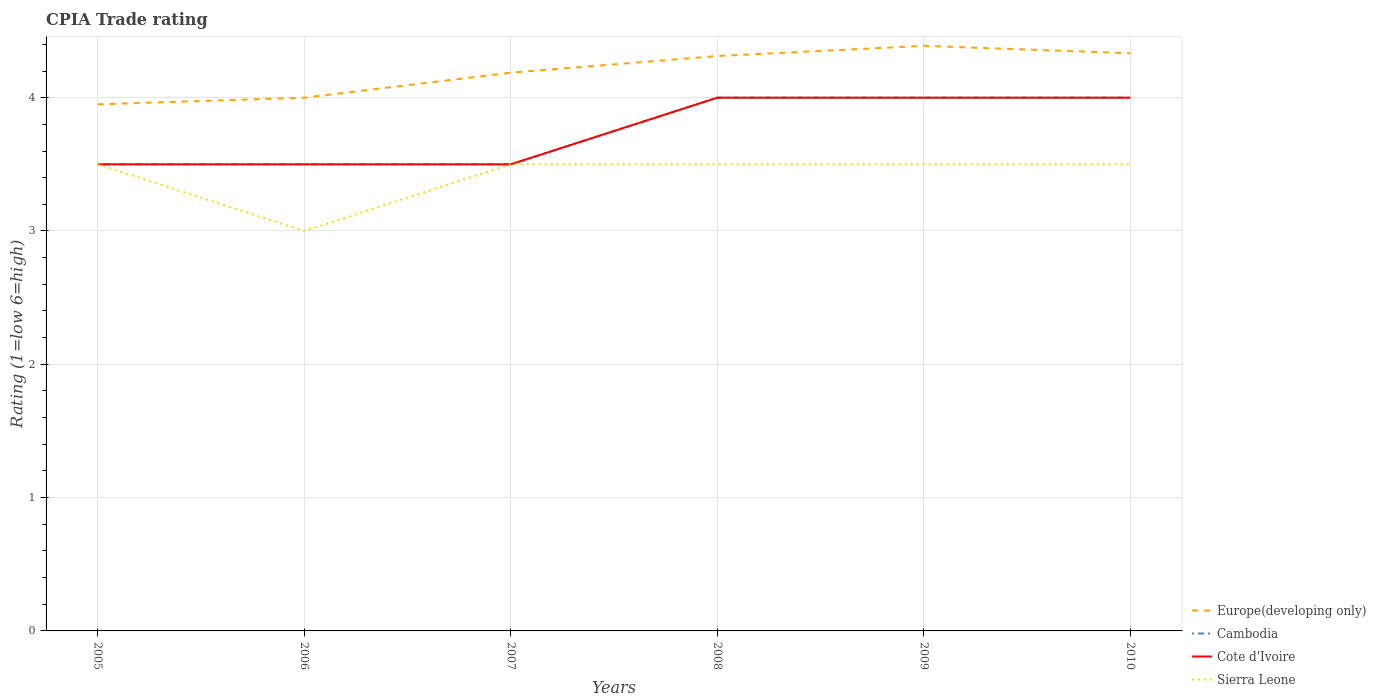How many different coloured lines are there?
Make the answer very short. 4. Does the line corresponding to Sierra Leone intersect with the line corresponding to Cote d'Ivoire?
Your answer should be compact. Yes. Is the number of lines equal to the number of legend labels?
Your answer should be compact. Yes. Across all years, what is the maximum CPIA rating in Sierra Leone?
Provide a short and direct response. 3. In which year was the CPIA rating in Sierra Leone maximum?
Offer a terse response. 2006. What is the total CPIA rating in Europe(developing only) in the graph?
Your answer should be very brief. -0.38. What is the difference between the highest and the lowest CPIA rating in Europe(developing only)?
Give a very brief answer. 3. Where does the legend appear in the graph?
Make the answer very short. Bottom right. How many legend labels are there?
Your answer should be compact. 4. How are the legend labels stacked?
Ensure brevity in your answer.  Vertical. What is the title of the graph?
Your response must be concise. CPIA Trade rating. Does "Macao" appear as one of the legend labels in the graph?
Your response must be concise. No. What is the label or title of the X-axis?
Make the answer very short. Years. What is the label or title of the Y-axis?
Your answer should be compact. Rating (1=low 6=high). What is the Rating (1=low 6=high) of Europe(developing only) in 2005?
Offer a terse response. 3.95. What is the Rating (1=low 6=high) of Sierra Leone in 2005?
Your response must be concise. 3.5. What is the Rating (1=low 6=high) in Europe(developing only) in 2006?
Ensure brevity in your answer.  4. What is the Rating (1=low 6=high) of Cambodia in 2006?
Your answer should be very brief. 3.5. What is the Rating (1=low 6=high) of Cote d'Ivoire in 2006?
Provide a short and direct response. 3.5. What is the Rating (1=low 6=high) in Sierra Leone in 2006?
Give a very brief answer. 3. What is the Rating (1=low 6=high) in Europe(developing only) in 2007?
Keep it short and to the point. 4.19. What is the Rating (1=low 6=high) in Cambodia in 2007?
Your answer should be very brief. 3.5. What is the Rating (1=low 6=high) of Cote d'Ivoire in 2007?
Offer a terse response. 3.5. What is the Rating (1=low 6=high) in Sierra Leone in 2007?
Ensure brevity in your answer.  3.5. What is the Rating (1=low 6=high) of Europe(developing only) in 2008?
Keep it short and to the point. 4.31. What is the Rating (1=low 6=high) of Cote d'Ivoire in 2008?
Your answer should be very brief. 4. What is the Rating (1=low 6=high) in Europe(developing only) in 2009?
Your answer should be very brief. 4.39. What is the Rating (1=low 6=high) in Cote d'Ivoire in 2009?
Offer a very short reply. 4. What is the Rating (1=low 6=high) in Europe(developing only) in 2010?
Give a very brief answer. 4.33. Across all years, what is the maximum Rating (1=low 6=high) of Europe(developing only)?
Provide a short and direct response. 4.39. Across all years, what is the maximum Rating (1=low 6=high) in Sierra Leone?
Provide a short and direct response. 3.5. Across all years, what is the minimum Rating (1=low 6=high) in Europe(developing only)?
Ensure brevity in your answer.  3.95. Across all years, what is the minimum Rating (1=low 6=high) in Cote d'Ivoire?
Offer a terse response. 3.5. What is the total Rating (1=low 6=high) of Europe(developing only) in the graph?
Offer a terse response. 25.17. What is the total Rating (1=low 6=high) in Cote d'Ivoire in the graph?
Give a very brief answer. 22.5. What is the difference between the Rating (1=low 6=high) in Europe(developing only) in 2005 and that in 2006?
Make the answer very short. -0.05. What is the difference between the Rating (1=low 6=high) of Cambodia in 2005 and that in 2006?
Make the answer very short. 0. What is the difference between the Rating (1=low 6=high) of Europe(developing only) in 2005 and that in 2007?
Make the answer very short. -0.24. What is the difference between the Rating (1=low 6=high) of Sierra Leone in 2005 and that in 2007?
Make the answer very short. 0. What is the difference between the Rating (1=low 6=high) in Europe(developing only) in 2005 and that in 2008?
Your response must be concise. -0.36. What is the difference between the Rating (1=low 6=high) in Cambodia in 2005 and that in 2008?
Offer a very short reply. -0.5. What is the difference between the Rating (1=low 6=high) of Europe(developing only) in 2005 and that in 2009?
Your response must be concise. -0.44. What is the difference between the Rating (1=low 6=high) of Cambodia in 2005 and that in 2009?
Keep it short and to the point. -0.5. What is the difference between the Rating (1=low 6=high) in Cote d'Ivoire in 2005 and that in 2009?
Offer a very short reply. -0.5. What is the difference between the Rating (1=low 6=high) of Sierra Leone in 2005 and that in 2009?
Offer a very short reply. 0. What is the difference between the Rating (1=low 6=high) of Europe(developing only) in 2005 and that in 2010?
Ensure brevity in your answer.  -0.38. What is the difference between the Rating (1=low 6=high) in Europe(developing only) in 2006 and that in 2007?
Ensure brevity in your answer.  -0.19. What is the difference between the Rating (1=low 6=high) in Cambodia in 2006 and that in 2007?
Your answer should be very brief. 0. What is the difference between the Rating (1=low 6=high) of Sierra Leone in 2006 and that in 2007?
Provide a succinct answer. -0.5. What is the difference between the Rating (1=low 6=high) of Europe(developing only) in 2006 and that in 2008?
Make the answer very short. -0.31. What is the difference between the Rating (1=low 6=high) of Cambodia in 2006 and that in 2008?
Give a very brief answer. -0.5. What is the difference between the Rating (1=low 6=high) in Sierra Leone in 2006 and that in 2008?
Keep it short and to the point. -0.5. What is the difference between the Rating (1=low 6=high) in Europe(developing only) in 2006 and that in 2009?
Your answer should be very brief. -0.39. What is the difference between the Rating (1=low 6=high) of Cote d'Ivoire in 2006 and that in 2009?
Your response must be concise. -0.5. What is the difference between the Rating (1=low 6=high) of Sierra Leone in 2006 and that in 2009?
Your response must be concise. -0.5. What is the difference between the Rating (1=low 6=high) of Cambodia in 2006 and that in 2010?
Provide a succinct answer. -0.5. What is the difference between the Rating (1=low 6=high) of Cote d'Ivoire in 2006 and that in 2010?
Provide a succinct answer. -0.5. What is the difference between the Rating (1=low 6=high) in Sierra Leone in 2006 and that in 2010?
Offer a very short reply. -0.5. What is the difference between the Rating (1=low 6=high) in Europe(developing only) in 2007 and that in 2008?
Your answer should be very brief. -0.12. What is the difference between the Rating (1=low 6=high) of Cambodia in 2007 and that in 2008?
Give a very brief answer. -0.5. What is the difference between the Rating (1=low 6=high) of Cote d'Ivoire in 2007 and that in 2008?
Offer a terse response. -0.5. What is the difference between the Rating (1=low 6=high) of Sierra Leone in 2007 and that in 2008?
Keep it short and to the point. 0. What is the difference between the Rating (1=low 6=high) of Europe(developing only) in 2007 and that in 2009?
Offer a terse response. -0.2. What is the difference between the Rating (1=low 6=high) in Cambodia in 2007 and that in 2009?
Ensure brevity in your answer.  -0.5. What is the difference between the Rating (1=low 6=high) of Cote d'Ivoire in 2007 and that in 2009?
Make the answer very short. -0.5. What is the difference between the Rating (1=low 6=high) in Sierra Leone in 2007 and that in 2009?
Provide a succinct answer. 0. What is the difference between the Rating (1=low 6=high) of Europe(developing only) in 2007 and that in 2010?
Give a very brief answer. -0.15. What is the difference between the Rating (1=low 6=high) in Cambodia in 2007 and that in 2010?
Offer a terse response. -0.5. What is the difference between the Rating (1=low 6=high) in Sierra Leone in 2007 and that in 2010?
Your response must be concise. 0. What is the difference between the Rating (1=low 6=high) of Europe(developing only) in 2008 and that in 2009?
Ensure brevity in your answer.  -0.08. What is the difference between the Rating (1=low 6=high) of Cambodia in 2008 and that in 2009?
Your answer should be compact. 0. What is the difference between the Rating (1=low 6=high) of Sierra Leone in 2008 and that in 2009?
Provide a succinct answer. 0. What is the difference between the Rating (1=low 6=high) of Europe(developing only) in 2008 and that in 2010?
Your answer should be compact. -0.02. What is the difference between the Rating (1=low 6=high) in Sierra Leone in 2008 and that in 2010?
Make the answer very short. 0. What is the difference between the Rating (1=low 6=high) in Europe(developing only) in 2009 and that in 2010?
Your answer should be compact. 0.06. What is the difference between the Rating (1=low 6=high) in Cote d'Ivoire in 2009 and that in 2010?
Give a very brief answer. 0. What is the difference between the Rating (1=low 6=high) in Sierra Leone in 2009 and that in 2010?
Offer a terse response. 0. What is the difference between the Rating (1=low 6=high) of Europe(developing only) in 2005 and the Rating (1=low 6=high) of Cambodia in 2006?
Make the answer very short. 0.45. What is the difference between the Rating (1=low 6=high) of Europe(developing only) in 2005 and the Rating (1=low 6=high) of Cote d'Ivoire in 2006?
Your response must be concise. 0.45. What is the difference between the Rating (1=low 6=high) of Europe(developing only) in 2005 and the Rating (1=low 6=high) of Sierra Leone in 2006?
Your response must be concise. 0.95. What is the difference between the Rating (1=low 6=high) in Europe(developing only) in 2005 and the Rating (1=low 6=high) in Cambodia in 2007?
Make the answer very short. 0.45. What is the difference between the Rating (1=low 6=high) in Europe(developing only) in 2005 and the Rating (1=low 6=high) in Cote d'Ivoire in 2007?
Offer a terse response. 0.45. What is the difference between the Rating (1=low 6=high) in Europe(developing only) in 2005 and the Rating (1=low 6=high) in Sierra Leone in 2007?
Keep it short and to the point. 0.45. What is the difference between the Rating (1=low 6=high) in Cambodia in 2005 and the Rating (1=low 6=high) in Cote d'Ivoire in 2007?
Make the answer very short. 0. What is the difference between the Rating (1=low 6=high) in Cote d'Ivoire in 2005 and the Rating (1=low 6=high) in Sierra Leone in 2007?
Provide a succinct answer. 0. What is the difference between the Rating (1=low 6=high) of Europe(developing only) in 2005 and the Rating (1=low 6=high) of Cote d'Ivoire in 2008?
Offer a terse response. -0.05. What is the difference between the Rating (1=low 6=high) of Europe(developing only) in 2005 and the Rating (1=low 6=high) of Sierra Leone in 2008?
Ensure brevity in your answer.  0.45. What is the difference between the Rating (1=low 6=high) of Cambodia in 2005 and the Rating (1=low 6=high) of Sierra Leone in 2008?
Give a very brief answer. 0. What is the difference between the Rating (1=low 6=high) in Europe(developing only) in 2005 and the Rating (1=low 6=high) in Cambodia in 2009?
Give a very brief answer. -0.05. What is the difference between the Rating (1=low 6=high) of Europe(developing only) in 2005 and the Rating (1=low 6=high) of Cote d'Ivoire in 2009?
Provide a short and direct response. -0.05. What is the difference between the Rating (1=low 6=high) in Europe(developing only) in 2005 and the Rating (1=low 6=high) in Sierra Leone in 2009?
Your answer should be compact. 0.45. What is the difference between the Rating (1=low 6=high) in Cambodia in 2005 and the Rating (1=low 6=high) in Cote d'Ivoire in 2009?
Offer a very short reply. -0.5. What is the difference between the Rating (1=low 6=high) in Europe(developing only) in 2005 and the Rating (1=low 6=high) in Cambodia in 2010?
Give a very brief answer. -0.05. What is the difference between the Rating (1=low 6=high) in Europe(developing only) in 2005 and the Rating (1=low 6=high) in Cote d'Ivoire in 2010?
Your answer should be very brief. -0.05. What is the difference between the Rating (1=low 6=high) of Europe(developing only) in 2005 and the Rating (1=low 6=high) of Sierra Leone in 2010?
Ensure brevity in your answer.  0.45. What is the difference between the Rating (1=low 6=high) in Cambodia in 2005 and the Rating (1=low 6=high) in Cote d'Ivoire in 2010?
Give a very brief answer. -0.5. What is the difference between the Rating (1=low 6=high) of Cambodia in 2005 and the Rating (1=low 6=high) of Sierra Leone in 2010?
Make the answer very short. 0. What is the difference between the Rating (1=low 6=high) of Cote d'Ivoire in 2005 and the Rating (1=low 6=high) of Sierra Leone in 2010?
Give a very brief answer. 0. What is the difference between the Rating (1=low 6=high) of Europe(developing only) in 2006 and the Rating (1=low 6=high) of Sierra Leone in 2007?
Provide a succinct answer. 0.5. What is the difference between the Rating (1=low 6=high) of Cote d'Ivoire in 2006 and the Rating (1=low 6=high) of Sierra Leone in 2007?
Give a very brief answer. 0. What is the difference between the Rating (1=low 6=high) in Europe(developing only) in 2006 and the Rating (1=low 6=high) in Cambodia in 2008?
Your answer should be compact. 0. What is the difference between the Rating (1=low 6=high) of Europe(developing only) in 2006 and the Rating (1=low 6=high) of Sierra Leone in 2008?
Offer a very short reply. 0.5. What is the difference between the Rating (1=low 6=high) in Cambodia in 2006 and the Rating (1=low 6=high) in Cote d'Ivoire in 2008?
Offer a terse response. -0.5. What is the difference between the Rating (1=low 6=high) in Cambodia in 2006 and the Rating (1=low 6=high) in Sierra Leone in 2008?
Ensure brevity in your answer.  0. What is the difference between the Rating (1=low 6=high) in Cote d'Ivoire in 2006 and the Rating (1=low 6=high) in Sierra Leone in 2008?
Provide a succinct answer. 0. What is the difference between the Rating (1=low 6=high) in Europe(developing only) in 2006 and the Rating (1=low 6=high) in Cambodia in 2009?
Make the answer very short. 0. What is the difference between the Rating (1=low 6=high) in Europe(developing only) in 2006 and the Rating (1=low 6=high) in Cote d'Ivoire in 2009?
Provide a short and direct response. 0. What is the difference between the Rating (1=low 6=high) in Europe(developing only) in 2006 and the Rating (1=low 6=high) in Sierra Leone in 2009?
Keep it short and to the point. 0.5. What is the difference between the Rating (1=low 6=high) of Cambodia in 2006 and the Rating (1=low 6=high) of Cote d'Ivoire in 2009?
Make the answer very short. -0.5. What is the difference between the Rating (1=low 6=high) in Cote d'Ivoire in 2006 and the Rating (1=low 6=high) in Sierra Leone in 2009?
Ensure brevity in your answer.  0. What is the difference between the Rating (1=low 6=high) of Europe(developing only) in 2006 and the Rating (1=low 6=high) of Cambodia in 2010?
Your answer should be compact. 0. What is the difference between the Rating (1=low 6=high) in Europe(developing only) in 2006 and the Rating (1=low 6=high) in Cote d'Ivoire in 2010?
Offer a terse response. 0. What is the difference between the Rating (1=low 6=high) in Cambodia in 2006 and the Rating (1=low 6=high) in Cote d'Ivoire in 2010?
Offer a terse response. -0.5. What is the difference between the Rating (1=low 6=high) of Cambodia in 2006 and the Rating (1=low 6=high) of Sierra Leone in 2010?
Offer a terse response. 0. What is the difference between the Rating (1=low 6=high) in Europe(developing only) in 2007 and the Rating (1=low 6=high) in Cambodia in 2008?
Offer a very short reply. 0.19. What is the difference between the Rating (1=low 6=high) in Europe(developing only) in 2007 and the Rating (1=low 6=high) in Cote d'Ivoire in 2008?
Your response must be concise. 0.19. What is the difference between the Rating (1=low 6=high) in Europe(developing only) in 2007 and the Rating (1=low 6=high) in Sierra Leone in 2008?
Your response must be concise. 0.69. What is the difference between the Rating (1=low 6=high) in Cambodia in 2007 and the Rating (1=low 6=high) in Cote d'Ivoire in 2008?
Make the answer very short. -0.5. What is the difference between the Rating (1=low 6=high) of Cambodia in 2007 and the Rating (1=low 6=high) of Sierra Leone in 2008?
Make the answer very short. 0. What is the difference between the Rating (1=low 6=high) of Europe(developing only) in 2007 and the Rating (1=low 6=high) of Cambodia in 2009?
Provide a short and direct response. 0.19. What is the difference between the Rating (1=low 6=high) in Europe(developing only) in 2007 and the Rating (1=low 6=high) in Cote d'Ivoire in 2009?
Offer a terse response. 0.19. What is the difference between the Rating (1=low 6=high) of Europe(developing only) in 2007 and the Rating (1=low 6=high) of Sierra Leone in 2009?
Offer a terse response. 0.69. What is the difference between the Rating (1=low 6=high) in Cote d'Ivoire in 2007 and the Rating (1=low 6=high) in Sierra Leone in 2009?
Provide a succinct answer. 0. What is the difference between the Rating (1=low 6=high) of Europe(developing only) in 2007 and the Rating (1=low 6=high) of Cambodia in 2010?
Make the answer very short. 0.19. What is the difference between the Rating (1=low 6=high) in Europe(developing only) in 2007 and the Rating (1=low 6=high) in Cote d'Ivoire in 2010?
Offer a very short reply. 0.19. What is the difference between the Rating (1=low 6=high) in Europe(developing only) in 2007 and the Rating (1=low 6=high) in Sierra Leone in 2010?
Ensure brevity in your answer.  0.69. What is the difference between the Rating (1=low 6=high) in Cambodia in 2007 and the Rating (1=low 6=high) in Cote d'Ivoire in 2010?
Offer a very short reply. -0.5. What is the difference between the Rating (1=low 6=high) of Europe(developing only) in 2008 and the Rating (1=low 6=high) of Cambodia in 2009?
Offer a very short reply. 0.31. What is the difference between the Rating (1=low 6=high) in Europe(developing only) in 2008 and the Rating (1=low 6=high) in Cote d'Ivoire in 2009?
Ensure brevity in your answer.  0.31. What is the difference between the Rating (1=low 6=high) in Europe(developing only) in 2008 and the Rating (1=low 6=high) in Sierra Leone in 2009?
Make the answer very short. 0.81. What is the difference between the Rating (1=low 6=high) of Cote d'Ivoire in 2008 and the Rating (1=low 6=high) of Sierra Leone in 2009?
Your answer should be very brief. 0.5. What is the difference between the Rating (1=low 6=high) of Europe(developing only) in 2008 and the Rating (1=low 6=high) of Cambodia in 2010?
Your response must be concise. 0.31. What is the difference between the Rating (1=low 6=high) of Europe(developing only) in 2008 and the Rating (1=low 6=high) of Cote d'Ivoire in 2010?
Your response must be concise. 0.31. What is the difference between the Rating (1=low 6=high) in Europe(developing only) in 2008 and the Rating (1=low 6=high) in Sierra Leone in 2010?
Your response must be concise. 0.81. What is the difference between the Rating (1=low 6=high) of Cambodia in 2008 and the Rating (1=low 6=high) of Cote d'Ivoire in 2010?
Give a very brief answer. 0. What is the difference between the Rating (1=low 6=high) of Cote d'Ivoire in 2008 and the Rating (1=low 6=high) of Sierra Leone in 2010?
Provide a succinct answer. 0.5. What is the difference between the Rating (1=low 6=high) in Europe(developing only) in 2009 and the Rating (1=low 6=high) in Cambodia in 2010?
Offer a terse response. 0.39. What is the difference between the Rating (1=low 6=high) in Europe(developing only) in 2009 and the Rating (1=low 6=high) in Cote d'Ivoire in 2010?
Keep it short and to the point. 0.39. What is the difference between the Rating (1=low 6=high) of Europe(developing only) in 2009 and the Rating (1=low 6=high) of Sierra Leone in 2010?
Offer a terse response. 0.89. What is the difference between the Rating (1=low 6=high) of Cambodia in 2009 and the Rating (1=low 6=high) of Sierra Leone in 2010?
Your answer should be very brief. 0.5. What is the average Rating (1=low 6=high) of Europe(developing only) per year?
Offer a very short reply. 4.2. What is the average Rating (1=low 6=high) of Cambodia per year?
Ensure brevity in your answer.  3.75. What is the average Rating (1=low 6=high) of Cote d'Ivoire per year?
Ensure brevity in your answer.  3.75. What is the average Rating (1=low 6=high) of Sierra Leone per year?
Make the answer very short. 3.42. In the year 2005, what is the difference between the Rating (1=low 6=high) in Europe(developing only) and Rating (1=low 6=high) in Cambodia?
Provide a short and direct response. 0.45. In the year 2005, what is the difference between the Rating (1=low 6=high) of Europe(developing only) and Rating (1=low 6=high) of Cote d'Ivoire?
Offer a terse response. 0.45. In the year 2005, what is the difference between the Rating (1=low 6=high) in Europe(developing only) and Rating (1=low 6=high) in Sierra Leone?
Your answer should be compact. 0.45. In the year 2005, what is the difference between the Rating (1=low 6=high) in Cambodia and Rating (1=low 6=high) in Cote d'Ivoire?
Make the answer very short. 0. In the year 2005, what is the difference between the Rating (1=low 6=high) in Cambodia and Rating (1=low 6=high) in Sierra Leone?
Your answer should be compact. 0. In the year 2006, what is the difference between the Rating (1=low 6=high) of Europe(developing only) and Rating (1=low 6=high) of Cote d'Ivoire?
Keep it short and to the point. 0.5. In the year 2006, what is the difference between the Rating (1=low 6=high) of Europe(developing only) and Rating (1=low 6=high) of Sierra Leone?
Offer a terse response. 1. In the year 2006, what is the difference between the Rating (1=low 6=high) in Cambodia and Rating (1=low 6=high) in Sierra Leone?
Your response must be concise. 0.5. In the year 2006, what is the difference between the Rating (1=low 6=high) in Cote d'Ivoire and Rating (1=low 6=high) in Sierra Leone?
Offer a very short reply. 0.5. In the year 2007, what is the difference between the Rating (1=low 6=high) of Europe(developing only) and Rating (1=low 6=high) of Cambodia?
Your answer should be very brief. 0.69. In the year 2007, what is the difference between the Rating (1=low 6=high) in Europe(developing only) and Rating (1=low 6=high) in Cote d'Ivoire?
Your answer should be very brief. 0.69. In the year 2007, what is the difference between the Rating (1=low 6=high) in Europe(developing only) and Rating (1=low 6=high) in Sierra Leone?
Your response must be concise. 0.69. In the year 2007, what is the difference between the Rating (1=low 6=high) in Cote d'Ivoire and Rating (1=low 6=high) in Sierra Leone?
Ensure brevity in your answer.  0. In the year 2008, what is the difference between the Rating (1=low 6=high) of Europe(developing only) and Rating (1=low 6=high) of Cambodia?
Your response must be concise. 0.31. In the year 2008, what is the difference between the Rating (1=low 6=high) of Europe(developing only) and Rating (1=low 6=high) of Cote d'Ivoire?
Provide a short and direct response. 0.31. In the year 2008, what is the difference between the Rating (1=low 6=high) in Europe(developing only) and Rating (1=low 6=high) in Sierra Leone?
Keep it short and to the point. 0.81. In the year 2008, what is the difference between the Rating (1=low 6=high) in Cambodia and Rating (1=low 6=high) in Cote d'Ivoire?
Provide a succinct answer. 0. In the year 2008, what is the difference between the Rating (1=low 6=high) of Cambodia and Rating (1=low 6=high) of Sierra Leone?
Provide a succinct answer. 0.5. In the year 2008, what is the difference between the Rating (1=low 6=high) of Cote d'Ivoire and Rating (1=low 6=high) of Sierra Leone?
Offer a terse response. 0.5. In the year 2009, what is the difference between the Rating (1=low 6=high) in Europe(developing only) and Rating (1=low 6=high) in Cambodia?
Provide a short and direct response. 0.39. In the year 2009, what is the difference between the Rating (1=low 6=high) in Europe(developing only) and Rating (1=low 6=high) in Cote d'Ivoire?
Your answer should be compact. 0.39. In the year 2009, what is the difference between the Rating (1=low 6=high) in Europe(developing only) and Rating (1=low 6=high) in Sierra Leone?
Your answer should be compact. 0.89. In the year 2009, what is the difference between the Rating (1=low 6=high) of Cambodia and Rating (1=low 6=high) of Sierra Leone?
Offer a very short reply. 0.5. In the year 2009, what is the difference between the Rating (1=low 6=high) of Cote d'Ivoire and Rating (1=low 6=high) of Sierra Leone?
Keep it short and to the point. 0.5. In the year 2010, what is the difference between the Rating (1=low 6=high) in Europe(developing only) and Rating (1=low 6=high) in Cambodia?
Give a very brief answer. 0.33. In the year 2010, what is the difference between the Rating (1=low 6=high) of Europe(developing only) and Rating (1=low 6=high) of Cote d'Ivoire?
Ensure brevity in your answer.  0.33. In the year 2010, what is the difference between the Rating (1=low 6=high) in Europe(developing only) and Rating (1=low 6=high) in Sierra Leone?
Your response must be concise. 0.83. In the year 2010, what is the difference between the Rating (1=low 6=high) of Cambodia and Rating (1=low 6=high) of Cote d'Ivoire?
Your response must be concise. 0. What is the ratio of the Rating (1=low 6=high) of Europe(developing only) in 2005 to that in 2006?
Offer a terse response. 0.99. What is the ratio of the Rating (1=low 6=high) of Cambodia in 2005 to that in 2006?
Provide a short and direct response. 1. What is the ratio of the Rating (1=low 6=high) in Cote d'Ivoire in 2005 to that in 2006?
Your answer should be compact. 1. What is the ratio of the Rating (1=low 6=high) in Sierra Leone in 2005 to that in 2006?
Offer a very short reply. 1.17. What is the ratio of the Rating (1=low 6=high) in Europe(developing only) in 2005 to that in 2007?
Provide a short and direct response. 0.94. What is the ratio of the Rating (1=low 6=high) in Sierra Leone in 2005 to that in 2007?
Offer a very short reply. 1. What is the ratio of the Rating (1=low 6=high) in Europe(developing only) in 2005 to that in 2008?
Your response must be concise. 0.92. What is the ratio of the Rating (1=low 6=high) in Cambodia in 2005 to that in 2008?
Keep it short and to the point. 0.88. What is the ratio of the Rating (1=low 6=high) in Cambodia in 2005 to that in 2009?
Your response must be concise. 0.88. What is the ratio of the Rating (1=low 6=high) of Europe(developing only) in 2005 to that in 2010?
Offer a very short reply. 0.91. What is the ratio of the Rating (1=low 6=high) of Cote d'Ivoire in 2005 to that in 2010?
Keep it short and to the point. 0.88. What is the ratio of the Rating (1=low 6=high) of Europe(developing only) in 2006 to that in 2007?
Your answer should be compact. 0.96. What is the ratio of the Rating (1=low 6=high) in Cambodia in 2006 to that in 2007?
Offer a terse response. 1. What is the ratio of the Rating (1=low 6=high) of Cote d'Ivoire in 2006 to that in 2007?
Make the answer very short. 1. What is the ratio of the Rating (1=low 6=high) of Europe(developing only) in 2006 to that in 2008?
Your response must be concise. 0.93. What is the ratio of the Rating (1=low 6=high) of Sierra Leone in 2006 to that in 2008?
Offer a terse response. 0.86. What is the ratio of the Rating (1=low 6=high) of Europe(developing only) in 2006 to that in 2009?
Your answer should be compact. 0.91. What is the ratio of the Rating (1=low 6=high) of Cote d'Ivoire in 2006 to that in 2009?
Your response must be concise. 0.88. What is the ratio of the Rating (1=low 6=high) in Cambodia in 2006 to that in 2010?
Keep it short and to the point. 0.88. What is the ratio of the Rating (1=low 6=high) in Sierra Leone in 2006 to that in 2010?
Make the answer very short. 0.86. What is the ratio of the Rating (1=low 6=high) in Europe(developing only) in 2007 to that in 2008?
Offer a terse response. 0.97. What is the ratio of the Rating (1=low 6=high) in Europe(developing only) in 2007 to that in 2009?
Keep it short and to the point. 0.95. What is the ratio of the Rating (1=low 6=high) of Cambodia in 2007 to that in 2009?
Keep it short and to the point. 0.88. What is the ratio of the Rating (1=low 6=high) of Cote d'Ivoire in 2007 to that in 2009?
Your answer should be very brief. 0.88. What is the ratio of the Rating (1=low 6=high) of Sierra Leone in 2007 to that in 2009?
Offer a terse response. 1. What is the ratio of the Rating (1=low 6=high) of Europe(developing only) in 2007 to that in 2010?
Make the answer very short. 0.97. What is the ratio of the Rating (1=low 6=high) of Cambodia in 2007 to that in 2010?
Provide a short and direct response. 0.88. What is the ratio of the Rating (1=low 6=high) of Cote d'Ivoire in 2007 to that in 2010?
Make the answer very short. 0.88. What is the ratio of the Rating (1=low 6=high) in Sierra Leone in 2007 to that in 2010?
Offer a very short reply. 1. What is the ratio of the Rating (1=low 6=high) of Europe(developing only) in 2008 to that in 2009?
Your response must be concise. 0.98. What is the ratio of the Rating (1=low 6=high) of Cote d'Ivoire in 2008 to that in 2009?
Provide a short and direct response. 1. What is the ratio of the Rating (1=low 6=high) in Europe(developing only) in 2008 to that in 2010?
Your answer should be compact. 1. What is the ratio of the Rating (1=low 6=high) in Europe(developing only) in 2009 to that in 2010?
Keep it short and to the point. 1.01. What is the ratio of the Rating (1=low 6=high) in Cote d'Ivoire in 2009 to that in 2010?
Give a very brief answer. 1. What is the ratio of the Rating (1=low 6=high) in Sierra Leone in 2009 to that in 2010?
Offer a terse response. 1. What is the difference between the highest and the second highest Rating (1=low 6=high) in Europe(developing only)?
Ensure brevity in your answer.  0.06. What is the difference between the highest and the second highest Rating (1=low 6=high) of Cambodia?
Your response must be concise. 0. What is the difference between the highest and the second highest Rating (1=low 6=high) of Cote d'Ivoire?
Keep it short and to the point. 0. What is the difference between the highest and the second highest Rating (1=low 6=high) in Sierra Leone?
Provide a short and direct response. 0. What is the difference between the highest and the lowest Rating (1=low 6=high) of Europe(developing only)?
Your response must be concise. 0.44. What is the difference between the highest and the lowest Rating (1=low 6=high) of Cote d'Ivoire?
Keep it short and to the point. 0.5. What is the difference between the highest and the lowest Rating (1=low 6=high) of Sierra Leone?
Ensure brevity in your answer.  0.5. 